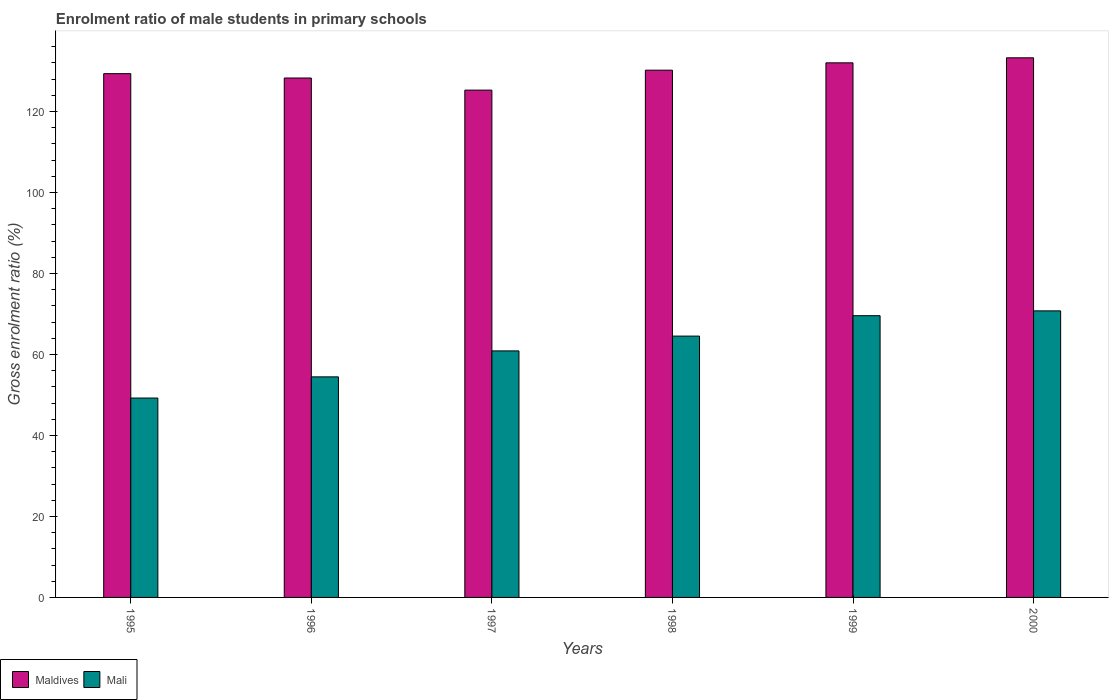Are the number of bars per tick equal to the number of legend labels?
Offer a very short reply. Yes. What is the enrolment ratio of male students in primary schools in Maldives in 1995?
Provide a succinct answer. 129.32. Across all years, what is the maximum enrolment ratio of male students in primary schools in Maldives?
Provide a succinct answer. 133.24. Across all years, what is the minimum enrolment ratio of male students in primary schools in Mali?
Ensure brevity in your answer.  49.23. In which year was the enrolment ratio of male students in primary schools in Mali minimum?
Ensure brevity in your answer.  1995. What is the total enrolment ratio of male students in primary schools in Maldives in the graph?
Your answer should be very brief. 778.24. What is the difference between the enrolment ratio of male students in primary schools in Mali in 1999 and that in 2000?
Your answer should be compact. -1.19. What is the difference between the enrolment ratio of male students in primary schools in Maldives in 1998 and the enrolment ratio of male students in primary schools in Mali in 1995?
Your answer should be compact. 80.95. What is the average enrolment ratio of male students in primary schools in Maldives per year?
Ensure brevity in your answer.  129.71. In the year 1999, what is the difference between the enrolment ratio of male students in primary schools in Maldives and enrolment ratio of male students in primary schools in Mali?
Provide a succinct answer. 62.43. In how many years, is the enrolment ratio of male students in primary schools in Maldives greater than 96 %?
Your answer should be compact. 6. What is the ratio of the enrolment ratio of male students in primary schools in Mali in 1995 to that in 2000?
Keep it short and to the point. 0.7. Is the enrolment ratio of male students in primary schools in Mali in 1998 less than that in 1999?
Offer a very short reply. Yes. What is the difference between the highest and the second highest enrolment ratio of male students in primary schools in Mali?
Keep it short and to the point. 1.19. What is the difference between the highest and the lowest enrolment ratio of male students in primary schools in Maldives?
Offer a very short reply. 7.98. What does the 2nd bar from the left in 2000 represents?
Make the answer very short. Mali. What does the 1st bar from the right in 1999 represents?
Offer a very short reply. Mali. How many years are there in the graph?
Give a very brief answer. 6. Does the graph contain any zero values?
Provide a short and direct response. No. What is the title of the graph?
Make the answer very short. Enrolment ratio of male students in primary schools. Does "Sierra Leone" appear as one of the legend labels in the graph?
Offer a very short reply. No. What is the label or title of the X-axis?
Your answer should be compact. Years. What is the Gross enrolment ratio (%) in Maldives in 1995?
Keep it short and to the point. 129.32. What is the Gross enrolment ratio (%) in Mali in 1995?
Keep it short and to the point. 49.23. What is the Gross enrolment ratio (%) in Maldives in 1996?
Provide a succinct answer. 128.25. What is the Gross enrolment ratio (%) in Mali in 1996?
Keep it short and to the point. 54.46. What is the Gross enrolment ratio (%) of Maldives in 1997?
Provide a succinct answer. 125.26. What is the Gross enrolment ratio (%) of Mali in 1997?
Provide a short and direct response. 60.87. What is the Gross enrolment ratio (%) of Maldives in 1998?
Provide a short and direct response. 130.18. What is the Gross enrolment ratio (%) in Mali in 1998?
Offer a very short reply. 64.52. What is the Gross enrolment ratio (%) in Maldives in 1999?
Your response must be concise. 132. What is the Gross enrolment ratio (%) of Mali in 1999?
Offer a very short reply. 69.56. What is the Gross enrolment ratio (%) in Maldives in 2000?
Offer a very short reply. 133.24. What is the Gross enrolment ratio (%) of Mali in 2000?
Provide a succinct answer. 70.75. Across all years, what is the maximum Gross enrolment ratio (%) in Maldives?
Ensure brevity in your answer.  133.24. Across all years, what is the maximum Gross enrolment ratio (%) of Mali?
Give a very brief answer. 70.75. Across all years, what is the minimum Gross enrolment ratio (%) in Maldives?
Your answer should be very brief. 125.26. Across all years, what is the minimum Gross enrolment ratio (%) in Mali?
Give a very brief answer. 49.23. What is the total Gross enrolment ratio (%) in Maldives in the graph?
Ensure brevity in your answer.  778.24. What is the total Gross enrolment ratio (%) of Mali in the graph?
Your answer should be compact. 369.4. What is the difference between the Gross enrolment ratio (%) in Maldives in 1995 and that in 1996?
Your response must be concise. 1.07. What is the difference between the Gross enrolment ratio (%) in Mali in 1995 and that in 1996?
Your answer should be very brief. -5.23. What is the difference between the Gross enrolment ratio (%) in Maldives in 1995 and that in 1997?
Make the answer very short. 4.06. What is the difference between the Gross enrolment ratio (%) in Mali in 1995 and that in 1997?
Give a very brief answer. -11.64. What is the difference between the Gross enrolment ratio (%) of Maldives in 1995 and that in 1998?
Your answer should be very brief. -0.86. What is the difference between the Gross enrolment ratio (%) in Mali in 1995 and that in 1998?
Provide a succinct answer. -15.29. What is the difference between the Gross enrolment ratio (%) of Maldives in 1995 and that in 1999?
Your answer should be very brief. -2.67. What is the difference between the Gross enrolment ratio (%) of Mali in 1995 and that in 1999?
Provide a succinct answer. -20.33. What is the difference between the Gross enrolment ratio (%) in Maldives in 1995 and that in 2000?
Provide a short and direct response. -3.92. What is the difference between the Gross enrolment ratio (%) in Mali in 1995 and that in 2000?
Your answer should be compact. -21.52. What is the difference between the Gross enrolment ratio (%) in Maldives in 1996 and that in 1997?
Your response must be concise. 2.99. What is the difference between the Gross enrolment ratio (%) of Mali in 1996 and that in 1997?
Your answer should be very brief. -6.41. What is the difference between the Gross enrolment ratio (%) of Maldives in 1996 and that in 1998?
Make the answer very short. -1.93. What is the difference between the Gross enrolment ratio (%) in Mali in 1996 and that in 1998?
Keep it short and to the point. -10.07. What is the difference between the Gross enrolment ratio (%) of Maldives in 1996 and that in 1999?
Offer a terse response. -3.75. What is the difference between the Gross enrolment ratio (%) of Mali in 1996 and that in 1999?
Your response must be concise. -15.11. What is the difference between the Gross enrolment ratio (%) of Maldives in 1996 and that in 2000?
Your answer should be compact. -4.99. What is the difference between the Gross enrolment ratio (%) in Mali in 1996 and that in 2000?
Keep it short and to the point. -16.3. What is the difference between the Gross enrolment ratio (%) of Maldives in 1997 and that in 1998?
Provide a succinct answer. -4.92. What is the difference between the Gross enrolment ratio (%) of Mali in 1997 and that in 1998?
Ensure brevity in your answer.  -3.66. What is the difference between the Gross enrolment ratio (%) of Maldives in 1997 and that in 1999?
Provide a succinct answer. -6.74. What is the difference between the Gross enrolment ratio (%) in Mali in 1997 and that in 1999?
Offer a very short reply. -8.69. What is the difference between the Gross enrolment ratio (%) of Maldives in 1997 and that in 2000?
Ensure brevity in your answer.  -7.98. What is the difference between the Gross enrolment ratio (%) of Mali in 1997 and that in 2000?
Your answer should be very brief. -9.88. What is the difference between the Gross enrolment ratio (%) in Maldives in 1998 and that in 1999?
Offer a very short reply. -1.81. What is the difference between the Gross enrolment ratio (%) of Mali in 1998 and that in 1999?
Provide a short and direct response. -5.04. What is the difference between the Gross enrolment ratio (%) in Maldives in 1998 and that in 2000?
Your response must be concise. -3.06. What is the difference between the Gross enrolment ratio (%) in Mali in 1998 and that in 2000?
Your answer should be compact. -6.23. What is the difference between the Gross enrolment ratio (%) in Maldives in 1999 and that in 2000?
Provide a short and direct response. -1.24. What is the difference between the Gross enrolment ratio (%) of Mali in 1999 and that in 2000?
Give a very brief answer. -1.19. What is the difference between the Gross enrolment ratio (%) of Maldives in 1995 and the Gross enrolment ratio (%) of Mali in 1996?
Provide a succinct answer. 74.87. What is the difference between the Gross enrolment ratio (%) in Maldives in 1995 and the Gross enrolment ratio (%) in Mali in 1997?
Keep it short and to the point. 68.45. What is the difference between the Gross enrolment ratio (%) of Maldives in 1995 and the Gross enrolment ratio (%) of Mali in 1998?
Provide a short and direct response. 64.8. What is the difference between the Gross enrolment ratio (%) of Maldives in 1995 and the Gross enrolment ratio (%) of Mali in 1999?
Your response must be concise. 59.76. What is the difference between the Gross enrolment ratio (%) of Maldives in 1995 and the Gross enrolment ratio (%) of Mali in 2000?
Ensure brevity in your answer.  58.57. What is the difference between the Gross enrolment ratio (%) of Maldives in 1996 and the Gross enrolment ratio (%) of Mali in 1997?
Your answer should be very brief. 67.38. What is the difference between the Gross enrolment ratio (%) in Maldives in 1996 and the Gross enrolment ratio (%) in Mali in 1998?
Your answer should be compact. 63.72. What is the difference between the Gross enrolment ratio (%) in Maldives in 1996 and the Gross enrolment ratio (%) in Mali in 1999?
Give a very brief answer. 58.69. What is the difference between the Gross enrolment ratio (%) in Maldives in 1996 and the Gross enrolment ratio (%) in Mali in 2000?
Offer a terse response. 57.5. What is the difference between the Gross enrolment ratio (%) in Maldives in 1997 and the Gross enrolment ratio (%) in Mali in 1998?
Your response must be concise. 60.73. What is the difference between the Gross enrolment ratio (%) of Maldives in 1997 and the Gross enrolment ratio (%) of Mali in 1999?
Offer a terse response. 55.7. What is the difference between the Gross enrolment ratio (%) in Maldives in 1997 and the Gross enrolment ratio (%) in Mali in 2000?
Provide a short and direct response. 54.51. What is the difference between the Gross enrolment ratio (%) in Maldives in 1998 and the Gross enrolment ratio (%) in Mali in 1999?
Give a very brief answer. 60.62. What is the difference between the Gross enrolment ratio (%) of Maldives in 1998 and the Gross enrolment ratio (%) of Mali in 2000?
Make the answer very short. 59.43. What is the difference between the Gross enrolment ratio (%) of Maldives in 1999 and the Gross enrolment ratio (%) of Mali in 2000?
Keep it short and to the point. 61.24. What is the average Gross enrolment ratio (%) in Maldives per year?
Keep it short and to the point. 129.71. What is the average Gross enrolment ratio (%) of Mali per year?
Offer a terse response. 61.57. In the year 1995, what is the difference between the Gross enrolment ratio (%) of Maldives and Gross enrolment ratio (%) of Mali?
Provide a short and direct response. 80.09. In the year 1996, what is the difference between the Gross enrolment ratio (%) in Maldives and Gross enrolment ratio (%) in Mali?
Provide a succinct answer. 73.79. In the year 1997, what is the difference between the Gross enrolment ratio (%) of Maldives and Gross enrolment ratio (%) of Mali?
Offer a very short reply. 64.39. In the year 1998, what is the difference between the Gross enrolment ratio (%) in Maldives and Gross enrolment ratio (%) in Mali?
Your answer should be compact. 65.66. In the year 1999, what is the difference between the Gross enrolment ratio (%) of Maldives and Gross enrolment ratio (%) of Mali?
Offer a very short reply. 62.43. In the year 2000, what is the difference between the Gross enrolment ratio (%) of Maldives and Gross enrolment ratio (%) of Mali?
Your answer should be compact. 62.48. What is the ratio of the Gross enrolment ratio (%) in Maldives in 1995 to that in 1996?
Provide a short and direct response. 1.01. What is the ratio of the Gross enrolment ratio (%) in Mali in 1995 to that in 1996?
Make the answer very short. 0.9. What is the ratio of the Gross enrolment ratio (%) in Maldives in 1995 to that in 1997?
Provide a succinct answer. 1.03. What is the ratio of the Gross enrolment ratio (%) in Mali in 1995 to that in 1997?
Make the answer very short. 0.81. What is the ratio of the Gross enrolment ratio (%) of Maldives in 1995 to that in 1998?
Make the answer very short. 0.99. What is the ratio of the Gross enrolment ratio (%) in Mali in 1995 to that in 1998?
Keep it short and to the point. 0.76. What is the ratio of the Gross enrolment ratio (%) of Maldives in 1995 to that in 1999?
Ensure brevity in your answer.  0.98. What is the ratio of the Gross enrolment ratio (%) in Mali in 1995 to that in 1999?
Provide a short and direct response. 0.71. What is the ratio of the Gross enrolment ratio (%) in Maldives in 1995 to that in 2000?
Give a very brief answer. 0.97. What is the ratio of the Gross enrolment ratio (%) in Mali in 1995 to that in 2000?
Offer a very short reply. 0.7. What is the ratio of the Gross enrolment ratio (%) of Maldives in 1996 to that in 1997?
Your answer should be compact. 1.02. What is the ratio of the Gross enrolment ratio (%) in Mali in 1996 to that in 1997?
Ensure brevity in your answer.  0.89. What is the ratio of the Gross enrolment ratio (%) in Maldives in 1996 to that in 1998?
Provide a short and direct response. 0.99. What is the ratio of the Gross enrolment ratio (%) in Mali in 1996 to that in 1998?
Make the answer very short. 0.84. What is the ratio of the Gross enrolment ratio (%) in Maldives in 1996 to that in 1999?
Give a very brief answer. 0.97. What is the ratio of the Gross enrolment ratio (%) in Mali in 1996 to that in 1999?
Your answer should be compact. 0.78. What is the ratio of the Gross enrolment ratio (%) of Maldives in 1996 to that in 2000?
Your answer should be very brief. 0.96. What is the ratio of the Gross enrolment ratio (%) of Mali in 1996 to that in 2000?
Your response must be concise. 0.77. What is the ratio of the Gross enrolment ratio (%) in Maldives in 1997 to that in 1998?
Keep it short and to the point. 0.96. What is the ratio of the Gross enrolment ratio (%) in Mali in 1997 to that in 1998?
Ensure brevity in your answer.  0.94. What is the ratio of the Gross enrolment ratio (%) in Maldives in 1997 to that in 1999?
Your answer should be compact. 0.95. What is the ratio of the Gross enrolment ratio (%) in Maldives in 1997 to that in 2000?
Provide a short and direct response. 0.94. What is the ratio of the Gross enrolment ratio (%) in Mali in 1997 to that in 2000?
Provide a succinct answer. 0.86. What is the ratio of the Gross enrolment ratio (%) in Maldives in 1998 to that in 1999?
Provide a succinct answer. 0.99. What is the ratio of the Gross enrolment ratio (%) of Mali in 1998 to that in 1999?
Provide a succinct answer. 0.93. What is the ratio of the Gross enrolment ratio (%) in Maldives in 1998 to that in 2000?
Your answer should be very brief. 0.98. What is the ratio of the Gross enrolment ratio (%) in Mali in 1998 to that in 2000?
Ensure brevity in your answer.  0.91. What is the ratio of the Gross enrolment ratio (%) in Maldives in 1999 to that in 2000?
Offer a terse response. 0.99. What is the ratio of the Gross enrolment ratio (%) in Mali in 1999 to that in 2000?
Make the answer very short. 0.98. What is the difference between the highest and the second highest Gross enrolment ratio (%) in Maldives?
Make the answer very short. 1.24. What is the difference between the highest and the second highest Gross enrolment ratio (%) in Mali?
Keep it short and to the point. 1.19. What is the difference between the highest and the lowest Gross enrolment ratio (%) in Maldives?
Your answer should be compact. 7.98. What is the difference between the highest and the lowest Gross enrolment ratio (%) in Mali?
Provide a short and direct response. 21.52. 